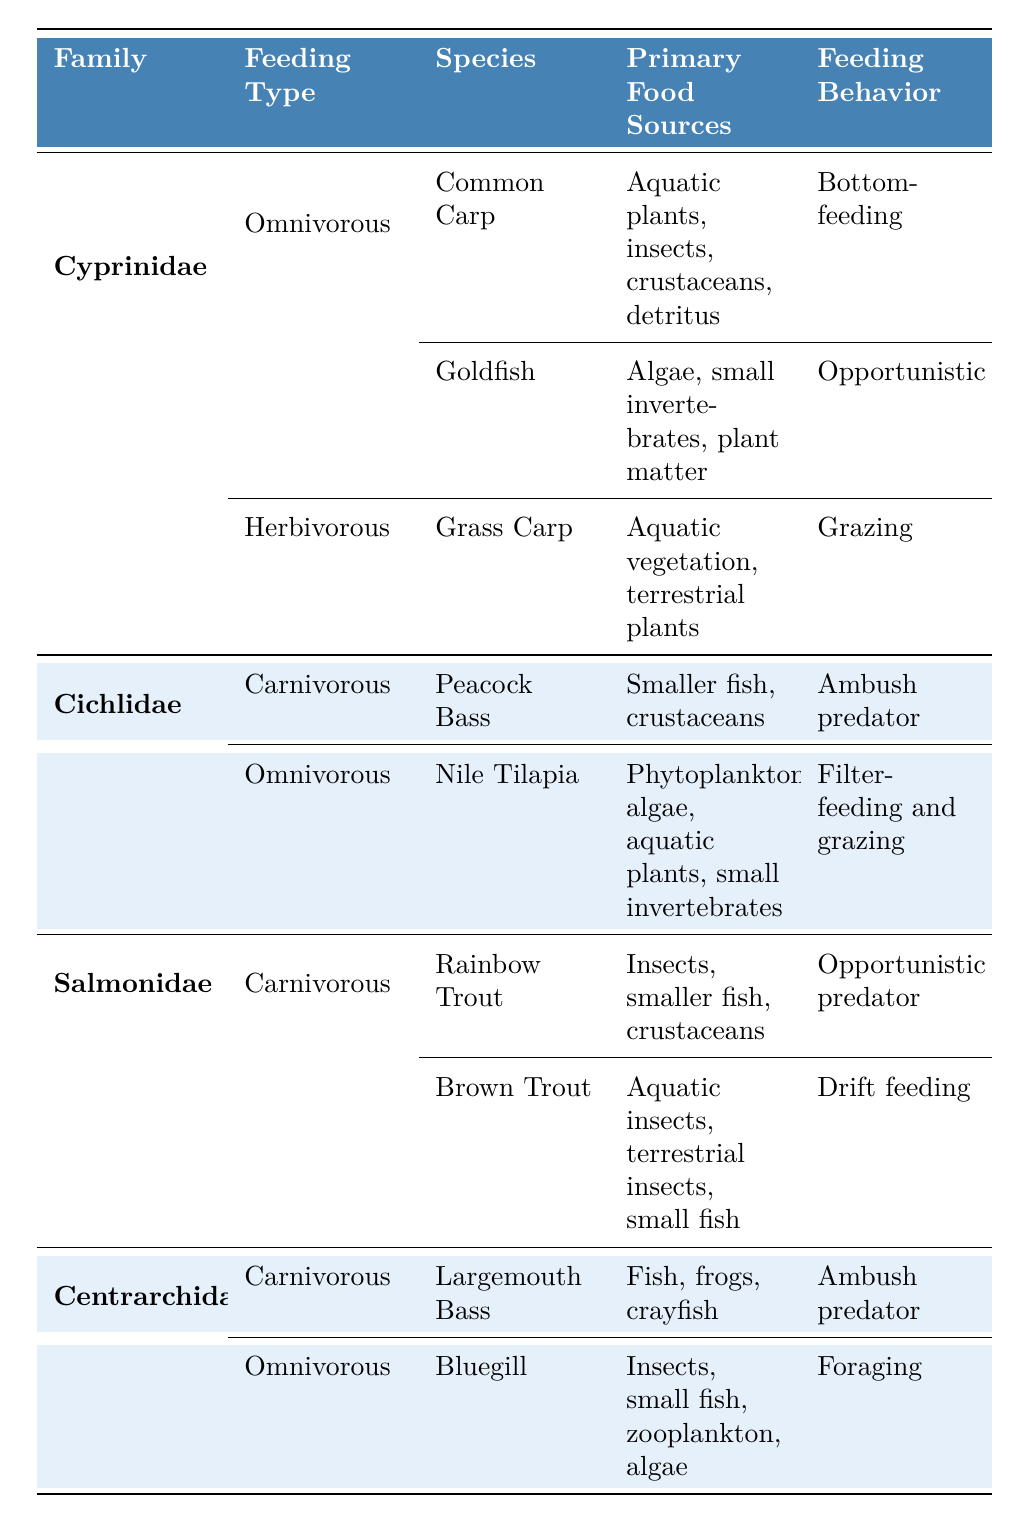What types of feeding habits are recorded for the Cyprinidae family? The table lists two feeding types for the Cyprinidae family: Omnivorous and Herbivorous. Omnivorous includes species like Common Carp and Goldfish, while Herbivorous includes Grass Carp.
Answer: Omnivorous and Herbivorous Which species in the Cichlidae family is known to be an ambush predator? The table indicates that the Peacock Bass in the Cichlidae family has a feeding behavior classified as an ambush predator.
Answer: Peacock Bass How many species from the Salmonidae family are represented in the table? The Salmonidae family has two species represented: Rainbow Trout and Brown Trout, both categorized under Carnivorous feeding type.
Answer: Two species Which fish families have carnivorous feeding types? The families listed with carnivorous feeding types are Cichlidae, Salmonidae, and Centrarchidae, based on the feeding type classifications in the table.
Answer: Cichlidae, Salmonidae, and Centrarchidae Which species among the listed families feeds during low light conditions? The Brown Trout from the Salmonidae family is noted for feeding during low light conditions according to the table’s details.
Answer: Brown Trout Are Goldfish herbivorous? The table categorizes Goldfish as omnivorous, not herbivorous, since their diet includes small invertebrates and plant matter.
Answer: No What primary food sources do Largemouth Bass prefer? The Largemouth Bass primarily feeds on fish, frogs, and crayfish, as detailed in the feeding habits section of the table.
Answer: Fish, frogs, crayfish Which family has the broadest range of feeding types represented in the table? The Cyprinidae family shows the most diversity with both omnivorous and herbivorous feeding types, while other families listed mainly exhibit either carnivorous or omnivorous types.
Answer: Cyprinidae If you were to average the peak feeding times for the species in the Centrarchidae family, which times would you consider? The peak feeding times for Centrarchidae species are listed as early morning and late evening for Largemouth Bass and throughout the day for Bluegill. As these times are not numerical, they cannot be averaged.
Answer: N/A Which family shows both opportunistic and ambush predators among its species? The Centrarchidae family shows both feeding behaviors with Largemouth Bass as an ambush predator and Bluegill exhibiting foraging (which is opportunistic in nature).
Answer: Centrarchidae 